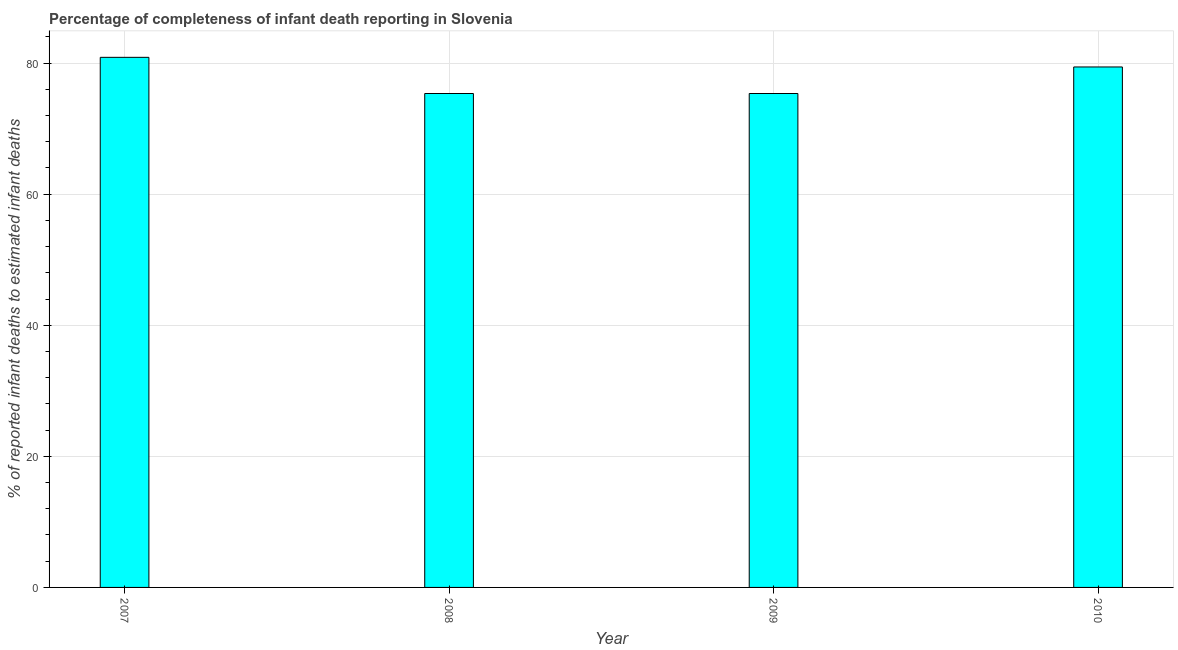Does the graph contain any zero values?
Give a very brief answer. No. Does the graph contain grids?
Keep it short and to the point. Yes. What is the title of the graph?
Ensure brevity in your answer.  Percentage of completeness of infant death reporting in Slovenia. What is the label or title of the X-axis?
Offer a very short reply. Year. What is the label or title of the Y-axis?
Give a very brief answer. % of reported infant deaths to estimated infant deaths. What is the completeness of infant death reporting in 2007?
Provide a short and direct response. 80.88. Across all years, what is the maximum completeness of infant death reporting?
Keep it short and to the point. 80.88. Across all years, what is the minimum completeness of infant death reporting?
Your answer should be very brief. 75.36. In which year was the completeness of infant death reporting maximum?
Make the answer very short. 2007. In which year was the completeness of infant death reporting minimum?
Offer a very short reply. 2008. What is the sum of the completeness of infant death reporting?
Your answer should be compact. 311.02. What is the difference between the completeness of infant death reporting in 2008 and 2009?
Provide a short and direct response. 0. What is the average completeness of infant death reporting per year?
Give a very brief answer. 77.75. What is the median completeness of infant death reporting?
Your answer should be compact. 77.39. Do a majority of the years between 2008 and 2009 (inclusive) have completeness of infant death reporting greater than 24 %?
Offer a terse response. Yes. What is the ratio of the completeness of infant death reporting in 2009 to that in 2010?
Your response must be concise. 0.95. Is the difference between the completeness of infant death reporting in 2007 and 2008 greater than the difference between any two years?
Offer a very short reply. Yes. What is the difference between the highest and the second highest completeness of infant death reporting?
Your answer should be compact. 1.47. What is the difference between the highest and the lowest completeness of infant death reporting?
Keep it short and to the point. 5.52. In how many years, is the completeness of infant death reporting greater than the average completeness of infant death reporting taken over all years?
Your answer should be very brief. 2. How many bars are there?
Keep it short and to the point. 4. Are all the bars in the graph horizontal?
Your answer should be very brief. No. How many years are there in the graph?
Offer a very short reply. 4. What is the % of reported infant deaths to estimated infant deaths in 2007?
Provide a short and direct response. 80.88. What is the % of reported infant deaths to estimated infant deaths in 2008?
Make the answer very short. 75.36. What is the % of reported infant deaths to estimated infant deaths of 2009?
Provide a short and direct response. 75.36. What is the % of reported infant deaths to estimated infant deaths in 2010?
Your answer should be very brief. 79.41. What is the difference between the % of reported infant deaths to estimated infant deaths in 2007 and 2008?
Offer a terse response. 5.52. What is the difference between the % of reported infant deaths to estimated infant deaths in 2007 and 2009?
Your answer should be very brief. 5.52. What is the difference between the % of reported infant deaths to estimated infant deaths in 2007 and 2010?
Make the answer very short. 1.47. What is the difference between the % of reported infant deaths to estimated infant deaths in 2008 and 2010?
Your answer should be compact. -4.05. What is the difference between the % of reported infant deaths to estimated infant deaths in 2009 and 2010?
Your answer should be compact. -4.05. What is the ratio of the % of reported infant deaths to estimated infant deaths in 2007 to that in 2008?
Your response must be concise. 1.07. What is the ratio of the % of reported infant deaths to estimated infant deaths in 2007 to that in 2009?
Your answer should be very brief. 1.07. What is the ratio of the % of reported infant deaths to estimated infant deaths in 2008 to that in 2009?
Your response must be concise. 1. What is the ratio of the % of reported infant deaths to estimated infant deaths in 2008 to that in 2010?
Your answer should be very brief. 0.95. What is the ratio of the % of reported infant deaths to estimated infant deaths in 2009 to that in 2010?
Keep it short and to the point. 0.95. 